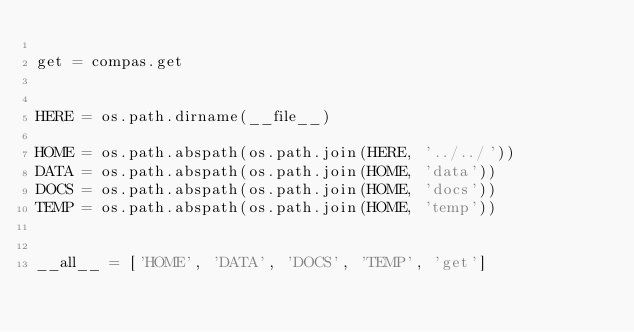<code> <loc_0><loc_0><loc_500><loc_500><_Python_>
get = compas.get


HERE = os.path.dirname(__file__)

HOME = os.path.abspath(os.path.join(HERE, '../../'))
DATA = os.path.abspath(os.path.join(HOME, 'data'))
DOCS = os.path.abspath(os.path.join(HOME, 'docs'))
TEMP = os.path.abspath(os.path.join(HOME, 'temp'))


__all__ = ['HOME', 'DATA', 'DOCS', 'TEMP', 'get']
</code> 